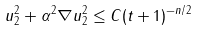Convert formula to latex. <formula><loc_0><loc_0><loc_500><loc_500>\| u \| ^ { 2 } _ { 2 } + \alpha ^ { 2 } \| \nabla u \| ^ { 2 } _ { 2 } \leq C ( t + 1 ) ^ { - n / 2 }</formula> 